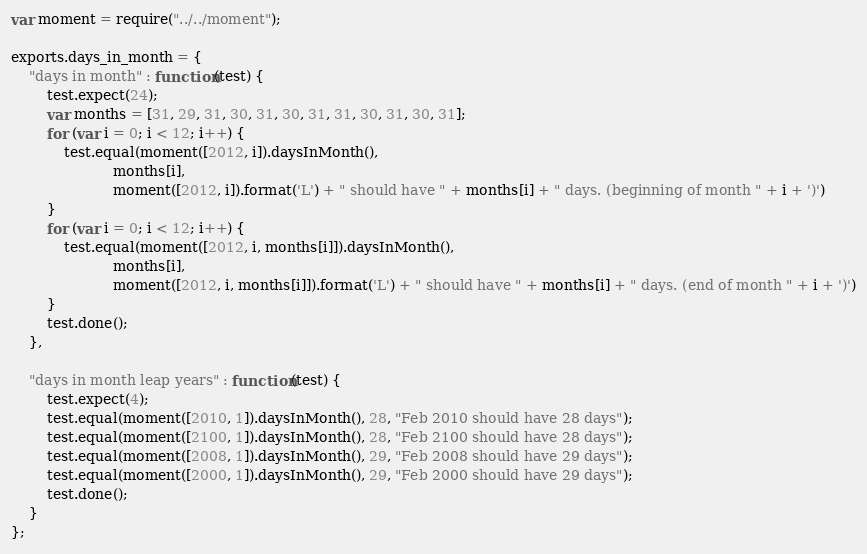<code> <loc_0><loc_0><loc_500><loc_500><_JavaScript_>var moment = require("../../moment");

exports.days_in_month = {
    "days in month" : function(test) {
        test.expect(24);
        var months = [31, 29, 31, 30, 31, 30, 31, 31, 30, 31, 30, 31];
        for (var i = 0; i < 12; i++) {
            test.equal(moment([2012, i]).daysInMonth(),
                       months[i],
                       moment([2012, i]).format('L') + " should have " + months[i] + " days. (beginning of month " + i + ')')
        }
        for (var i = 0; i < 12; i++) {
            test.equal(moment([2012, i, months[i]]).daysInMonth(),
                       months[i],
                       moment([2012, i, months[i]]).format('L') + " should have " + months[i] + " days. (end of month " + i + ')')
        }
        test.done();
    },

    "days in month leap years" : function(test) {
        test.expect(4);
        test.equal(moment([2010, 1]).daysInMonth(), 28, "Feb 2010 should have 28 days");
        test.equal(moment([2100, 1]).daysInMonth(), 28, "Feb 2100 should have 28 days");
        test.equal(moment([2008, 1]).daysInMonth(), 29, "Feb 2008 should have 29 days");
        test.equal(moment([2000, 1]).daysInMonth(), 29, "Feb 2000 should have 29 days");
        test.done();
    }
};
</code> 